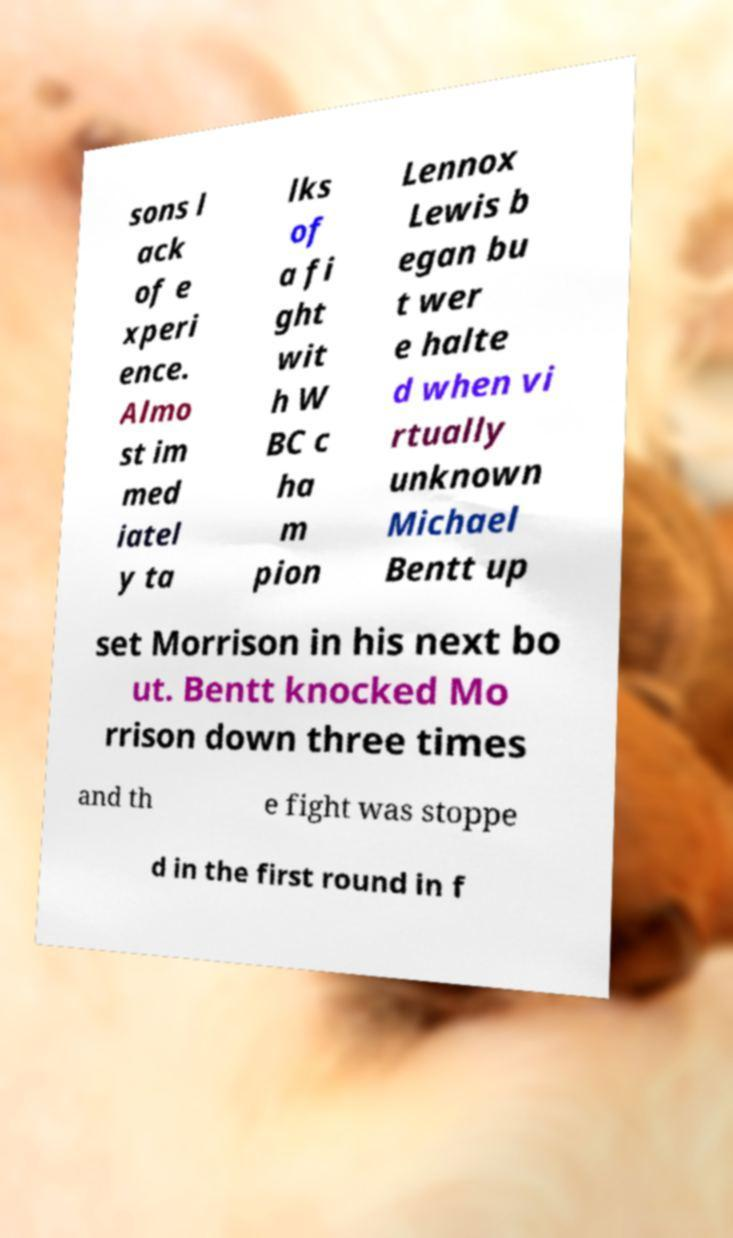Can you accurately transcribe the text from the provided image for me? sons l ack of e xperi ence. Almo st im med iatel y ta lks of a fi ght wit h W BC c ha m pion Lennox Lewis b egan bu t wer e halte d when vi rtually unknown Michael Bentt up set Morrison in his next bo ut. Bentt knocked Mo rrison down three times and th e fight was stoppe d in the first round in f 